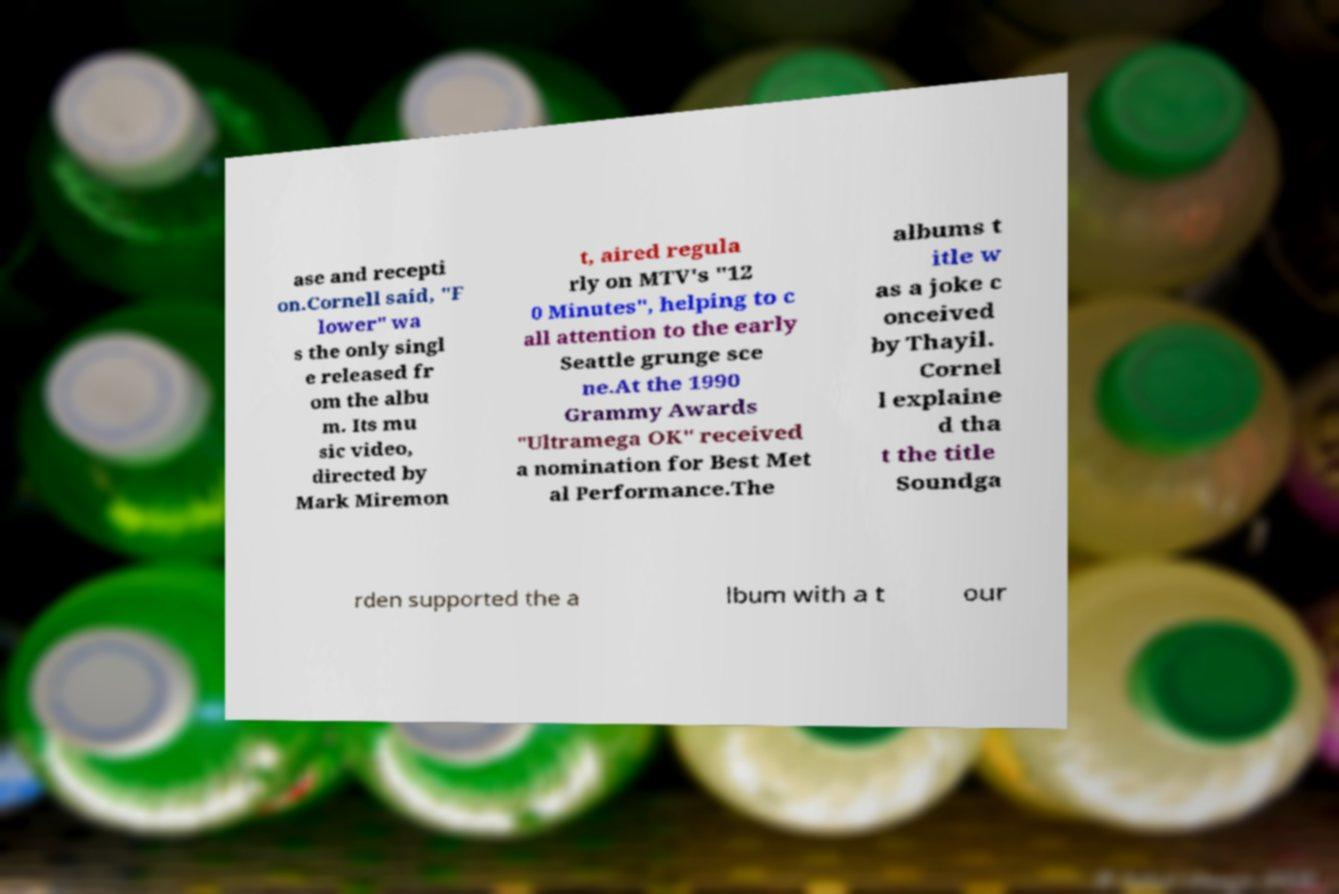Can you read and provide the text displayed in the image?This photo seems to have some interesting text. Can you extract and type it out for me? ase and recepti on.Cornell said, "F lower" wa s the only singl e released fr om the albu m. Its mu sic video, directed by Mark Miremon t, aired regula rly on MTV's "12 0 Minutes", helping to c all attention to the early Seattle grunge sce ne.At the 1990 Grammy Awards "Ultramega OK" received a nomination for Best Met al Performance.The albums t itle w as a joke c onceived by Thayil. Cornel l explaine d tha t the title Soundga rden supported the a lbum with a t our 